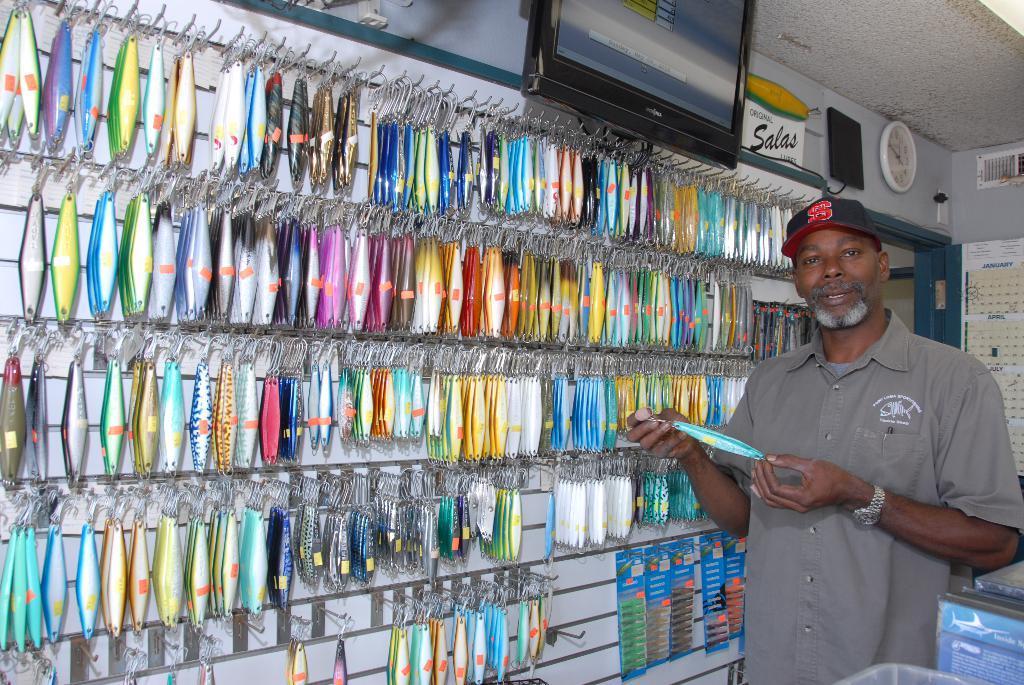Could you give a brief overview of what you see in this image? In this image there are colorful objects are at left side of this image and there is one person standing at right side of this person is holding an object and wearing a cap,and there is one television at top of this image and there is clock at right side of this image and there are some other objects attached to the wall at right side of this image. 